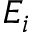Convert formula to latex. <formula><loc_0><loc_0><loc_500><loc_500>E _ { i }</formula> 